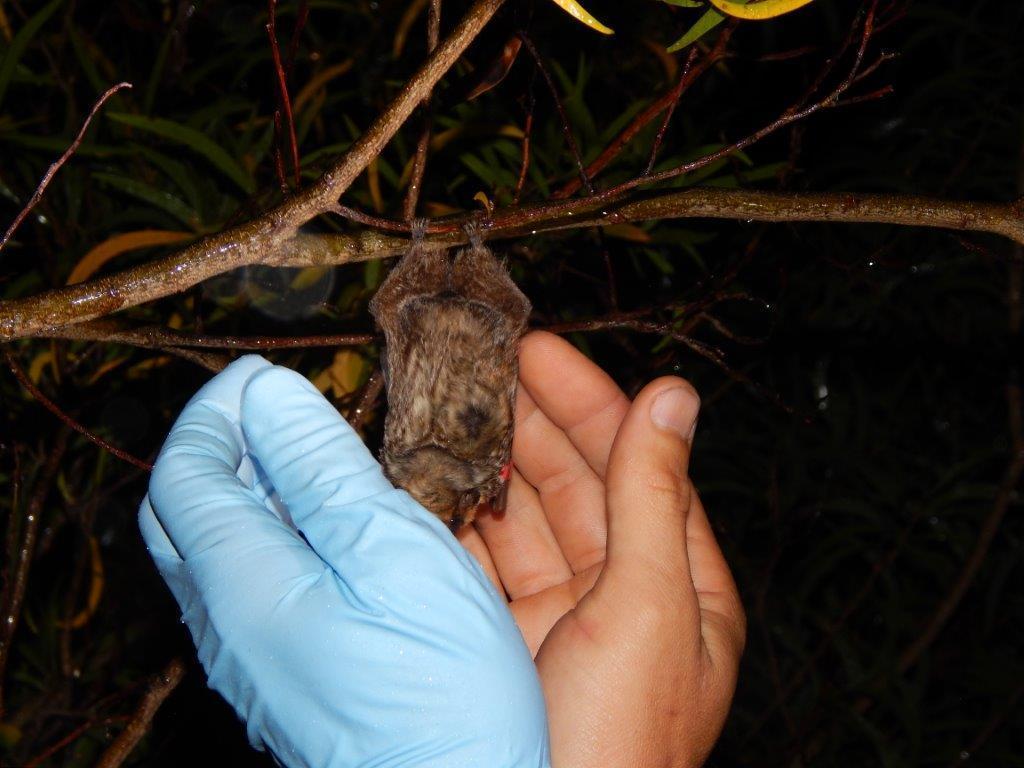Can you describe this image briefly? In this picture I can see there is a bat hanging to the branch and there is a person holding it. There are few leaves and the backdrop is dark. 